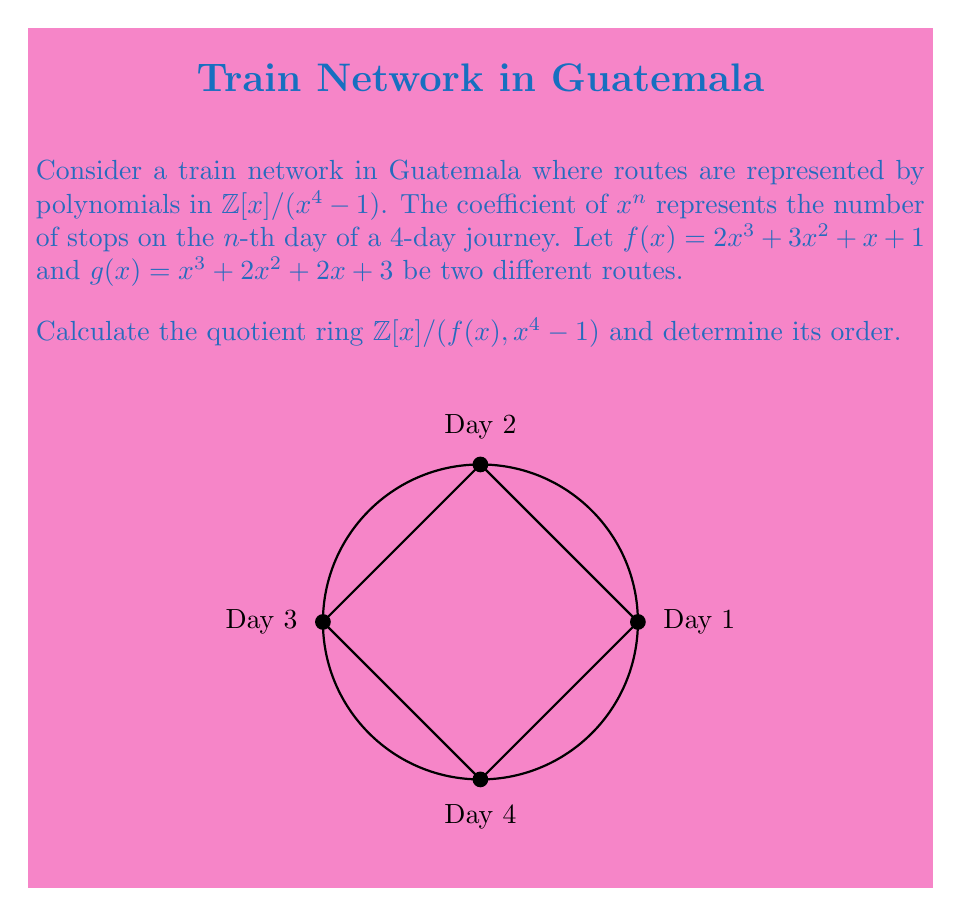Could you help me with this problem? Let's approach this step-by-step:

1) First, we need to find the GCD of $f(x)$ and $x^4-1$ in $\mathbb{Z}[x]$.

2) We can use the Euclidean algorithm:
   $x^4 - 1 = (x - \frac{1}{2})(2x^3 + 3x^2 + x + 1) + (\frac{5}{2}x^2 + \frac{1}{2}x + \frac{1}{2})$

3) Since the remainder is not in $\mathbb{Z}[x]$, we can conclude that $f(x)$ and $x^4-1$ are coprime in $\mathbb{Z}[x]$.

4) This means that $(f(x),x^4-1) = (1)$ in $\mathbb{Z}[x]$.

5) Therefore, $\mathbb{Z}[x]/(f(x),x^4-1) \cong \mathbb{Z}[x]/(1) \cong \{0\}$.

6) The quotient ring is the zero ring, which has only one element.

7) Thus, the order of the quotient ring is 1.
Answer: $\{0\}$, order 1 